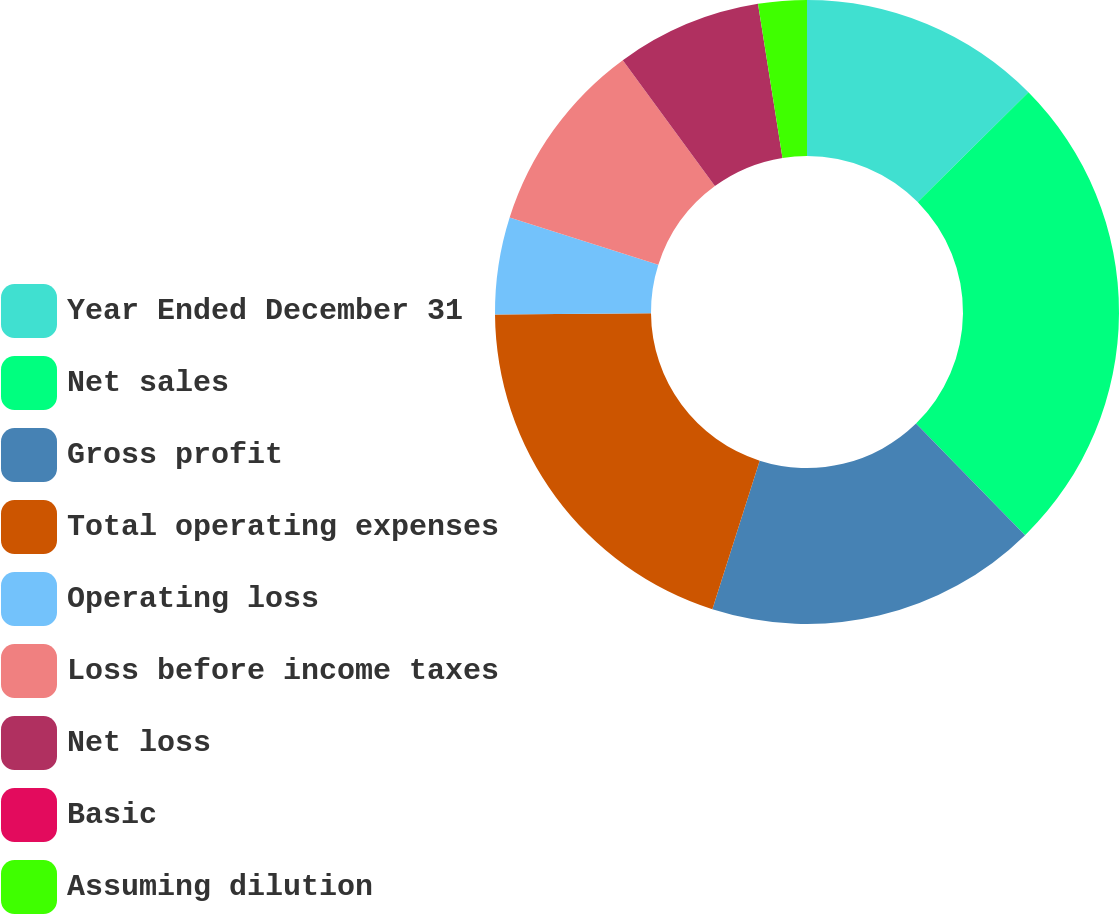Convert chart to OTSL. <chart><loc_0><loc_0><loc_500><loc_500><pie_chart><fcel>Year Ended December 31<fcel>Net sales<fcel>Gross profit<fcel>Total operating expenses<fcel>Operating loss<fcel>Loss before income taxes<fcel>Net loss<fcel>Basic<fcel>Assuming dilution<nl><fcel>12.56%<fcel>25.12%<fcel>17.22%<fcel>19.96%<fcel>5.03%<fcel>10.05%<fcel>7.54%<fcel>0.0%<fcel>2.51%<nl></chart> 